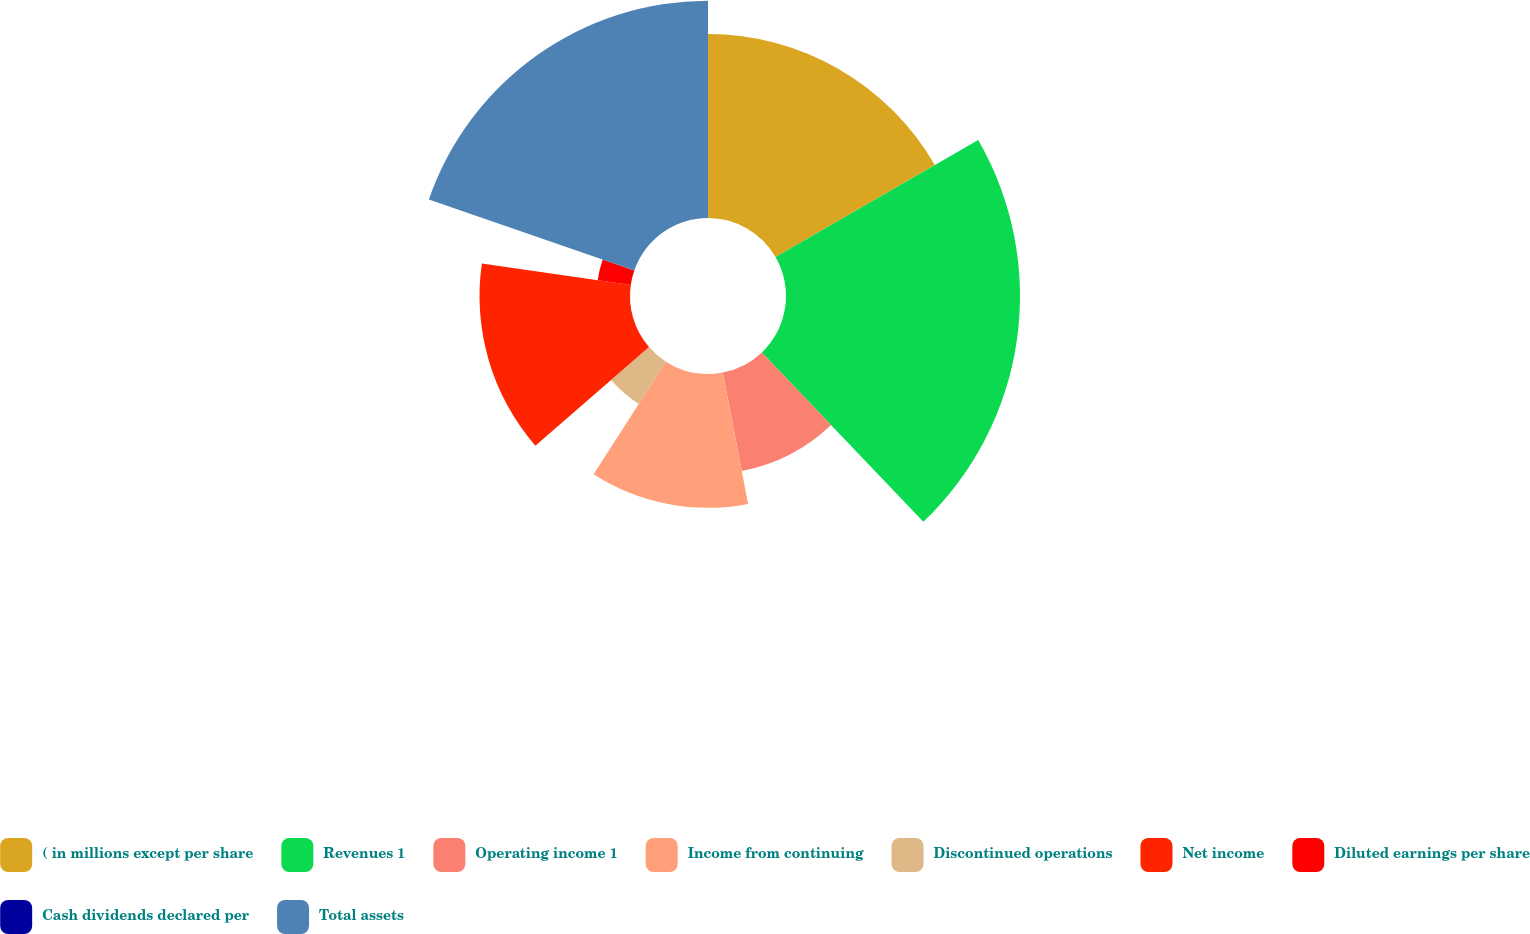<chart> <loc_0><loc_0><loc_500><loc_500><pie_chart><fcel>( in millions except per share<fcel>Revenues 1<fcel>Operating income 1<fcel>Income from continuing<fcel>Discontinued operations<fcel>Net income<fcel>Diluted earnings per share<fcel>Cash dividends declared per<fcel>Total assets<nl><fcel>16.67%<fcel>21.21%<fcel>9.09%<fcel>12.12%<fcel>4.55%<fcel>13.64%<fcel>3.03%<fcel>0.0%<fcel>19.7%<nl></chart> 